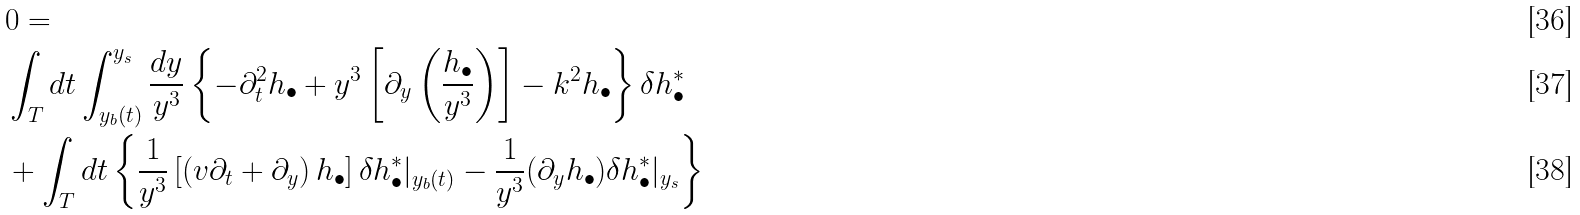<formula> <loc_0><loc_0><loc_500><loc_500>& 0 = \\ & \int _ { T } d t \int _ { y _ { b } ( t ) } ^ { y _ { s } } \frac { d y } { y ^ { 3 } } \left \{ - \partial _ { t } ^ { 2 } h _ { \bullet } + y ^ { 3 } \left [ \partial _ { y } \left ( \frac { h _ { \bullet } } { y ^ { 3 } } \right ) \right ] - k ^ { 2 } h _ { \bullet } \right \} \delta h _ { \bullet } ^ { * } \\ & + \int _ { T } d t \left \{ \frac { 1 } { y ^ { 3 } } \left [ \left ( v \partial _ { t } + \partial _ { y } \right ) h _ { \bullet } \right ] \delta h _ { \bullet } ^ { * } | _ { y _ { b } ( t ) } - \frac { 1 } { y ^ { 3 } } ( \partial _ { y } h _ { \bullet } ) \delta h _ { \bullet } ^ { * } | _ { y _ { s } } \right \}</formula> 